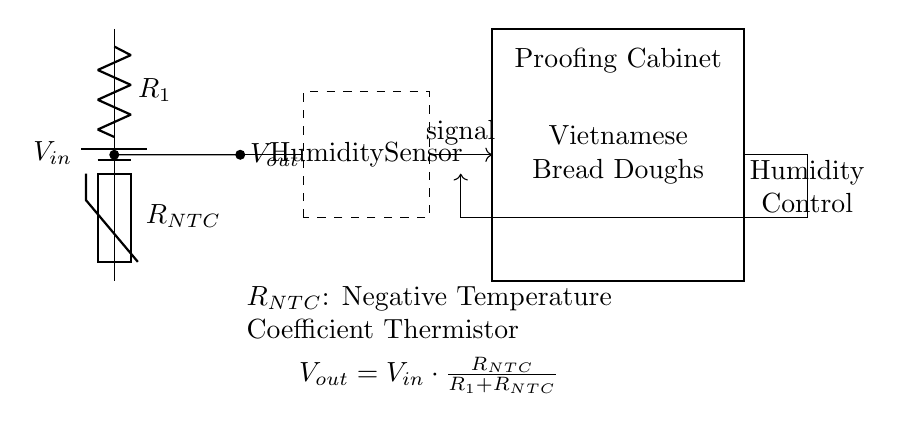What is the type of the thermistor in this circuit? The circuit diagram identifies the thermistor as a Negative Temperature Coefficient (NTC) thermistor, which means its resistance decreases as the temperature increases. This is indicated by the label placed next to the thermistor symbol in the diagram.
Answer: NTC What is the output voltage formula? The output voltage formula is shown in the annotations of the circuit. It is derived from the voltage divider principle, where the output voltage across the resistor is given by the formula: Vout = Vin * (RNTC / (R1 + RNTC)). This formula determines how the output voltage depends on the resistances involved in the voltage divider.
Answer: Vout = Vin * (RNTC / (R1 + RNTC)) How many components are in the voltage divider circuit? In the diagram, there are three main components present: one battery (V_in), one resistor (R_1), and one thermistor (R_NTC). Counting these components provides the total for the voltage divider section of the circuit.
Answer: Three What does the humidity sensor do in this circuit? The humidity sensor, indicated in the dashed rectangle, is integrated into the circuit to monitor the humidity levels within the proofing cabinet. It senses the environmental moisture, which is crucial for the optimal proofing of bread doughs and affects the feedback to the control system.
Answer: Monitor humidity What happens to Vout if R1 is increased? Increasing R1 would lead to a decrease in the output voltage Vout. According to the voltage divider formula, increasing R1 while keeping RNTC constant results in a smaller ratio of RNTC to (R1 + RNTC), thus reducing Vout. The mathematical reasoning follows that as the denominator in the fraction grows, the overall fraction decreases.
Answer: Decreases What does the control system do in relation to the humidity readings? The control system adjusts the humidity levels based on the signal received from the humidity sensor. If the humidity readings are outside of the desired range for proofing Vietnamese bread doughs, the control system will take action to rectify this, ensuring that the dough rises properly.
Answer: Adjust humidity 